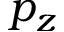Convert formula to latex. <formula><loc_0><loc_0><loc_500><loc_500>p _ { z }</formula> 